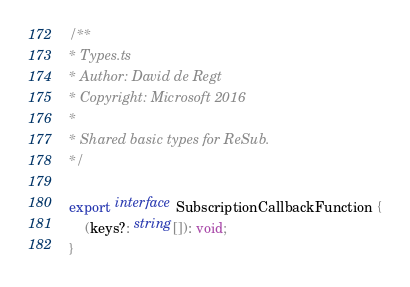<code> <loc_0><loc_0><loc_500><loc_500><_TypeScript_>/**
* Types.ts
* Author: David de Regt
* Copyright: Microsoft 2016
*
* Shared basic types for ReSub.
*/

export interface SubscriptionCallbackFunction {
    (keys?: string[]): void;
}

</code> 